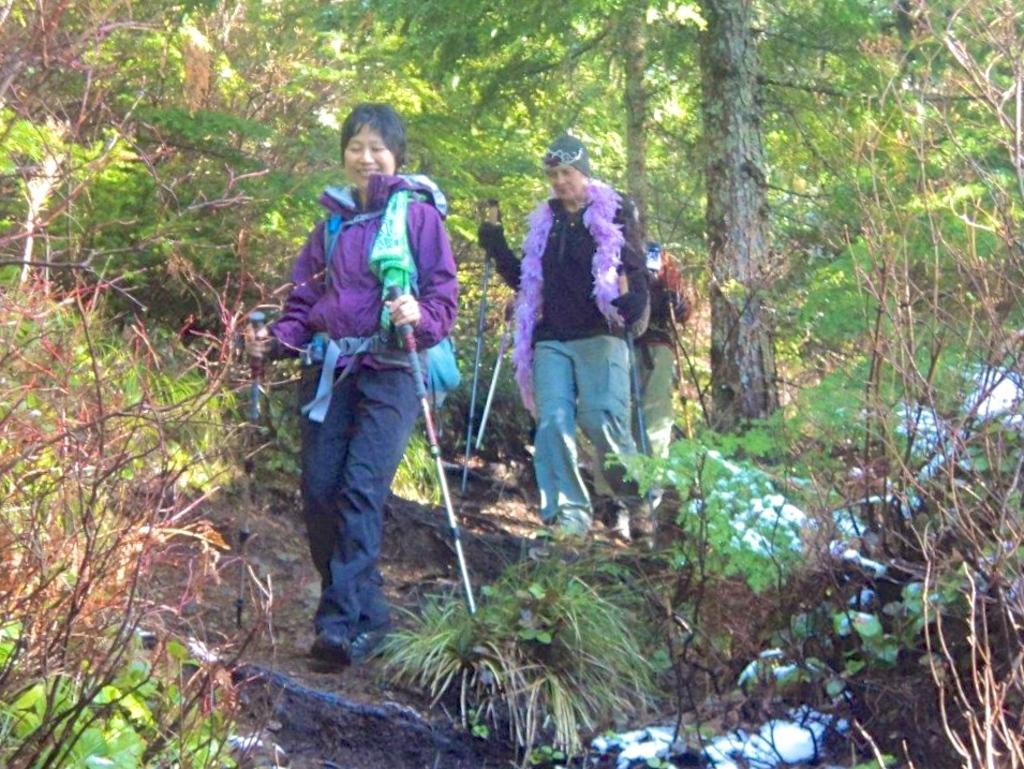How would you summarize this image in a sentence or two? In this image we can see three persons are walking and holding the objects, behind them there are some trees and plants. 